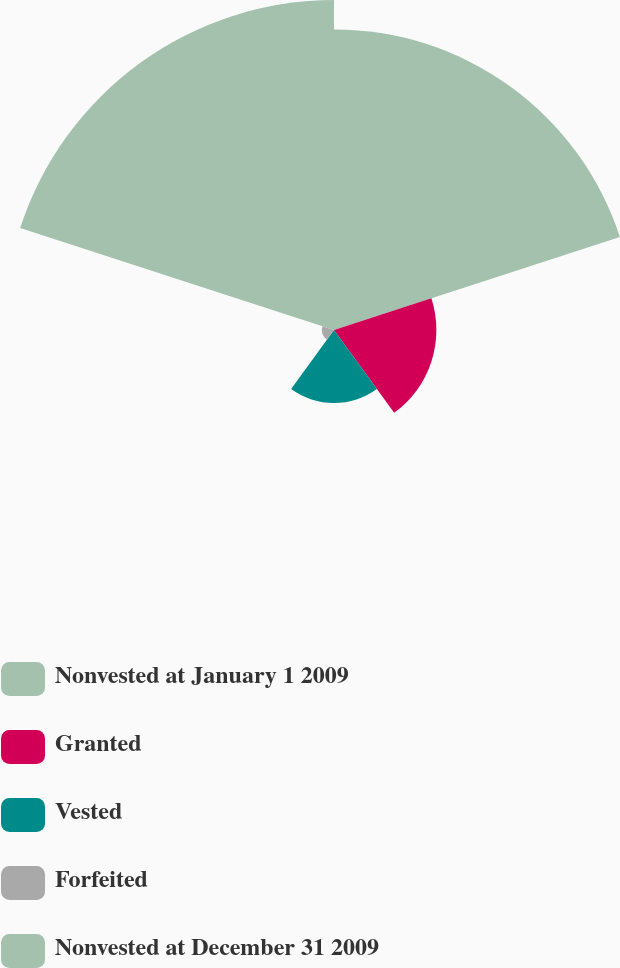Convert chart to OTSL. <chart><loc_0><loc_0><loc_500><loc_500><pie_chart><fcel>Nonvested at January 1 2009<fcel>Granted<fcel>Vested<fcel>Forfeited<fcel>Nonvested at December 31 2009<nl><fcel>36.74%<fcel>12.51%<fcel>8.92%<fcel>1.49%<fcel>40.33%<nl></chart> 